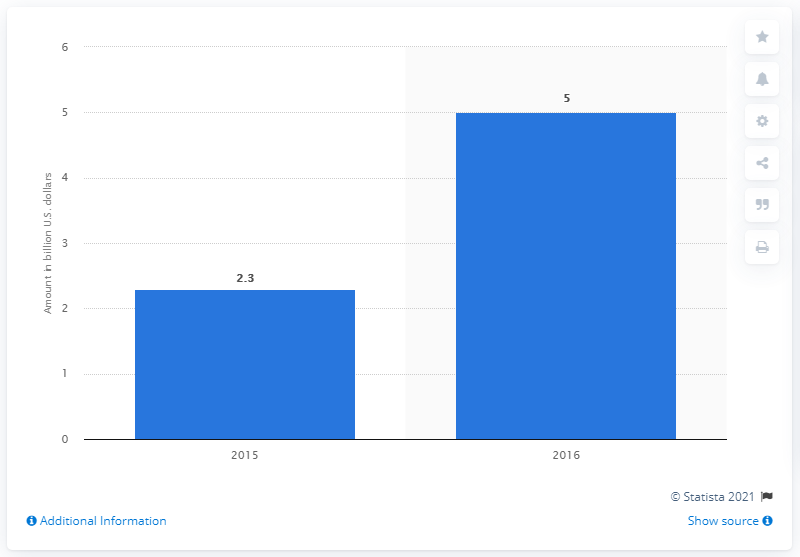Mention a couple of crucial points in this snapshot. The product of the values represented by the bars is 11.5. The sum of the lowest amount wagered on Counter-Strike and its average across all years is 5.95. 